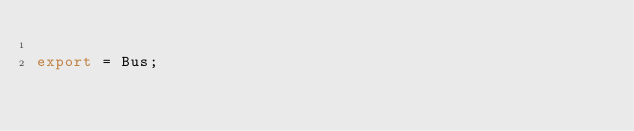<code> <loc_0><loc_0><loc_500><loc_500><_TypeScript_>
export = Bus;
</code> 